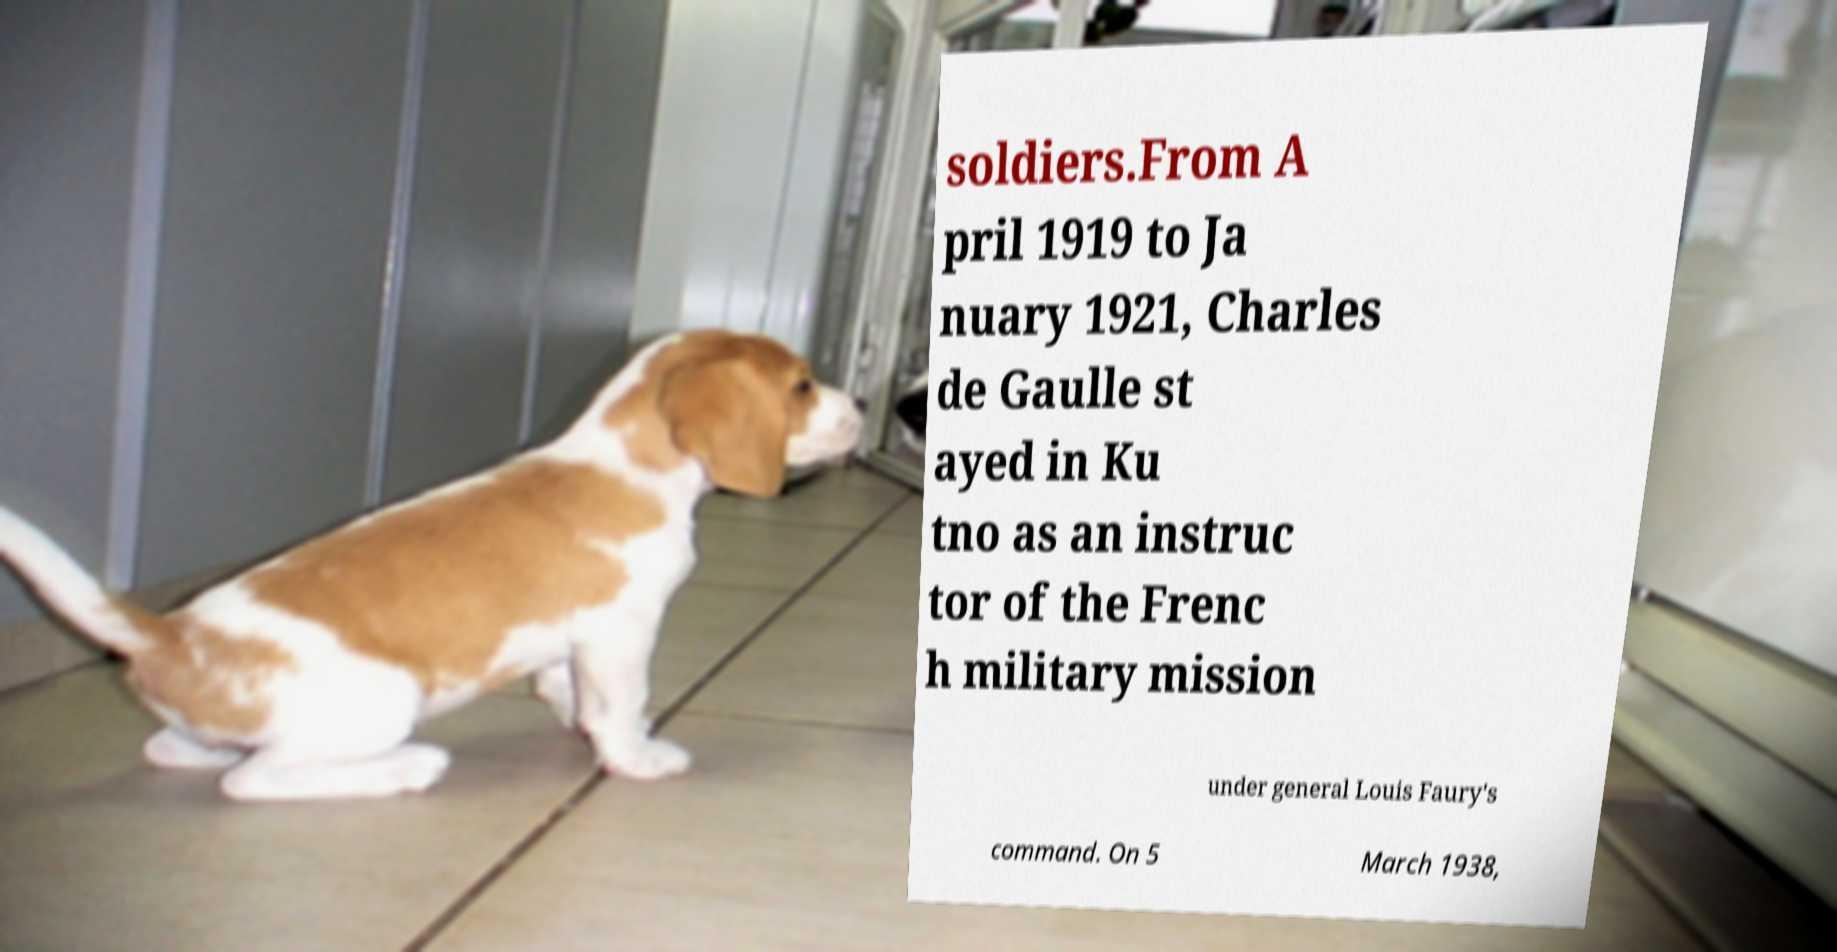Please read and relay the text visible in this image. What does it say? soldiers.From A pril 1919 to Ja nuary 1921, Charles de Gaulle st ayed in Ku tno as an instruc tor of the Frenc h military mission under general Louis Faury's command. On 5 March 1938, 